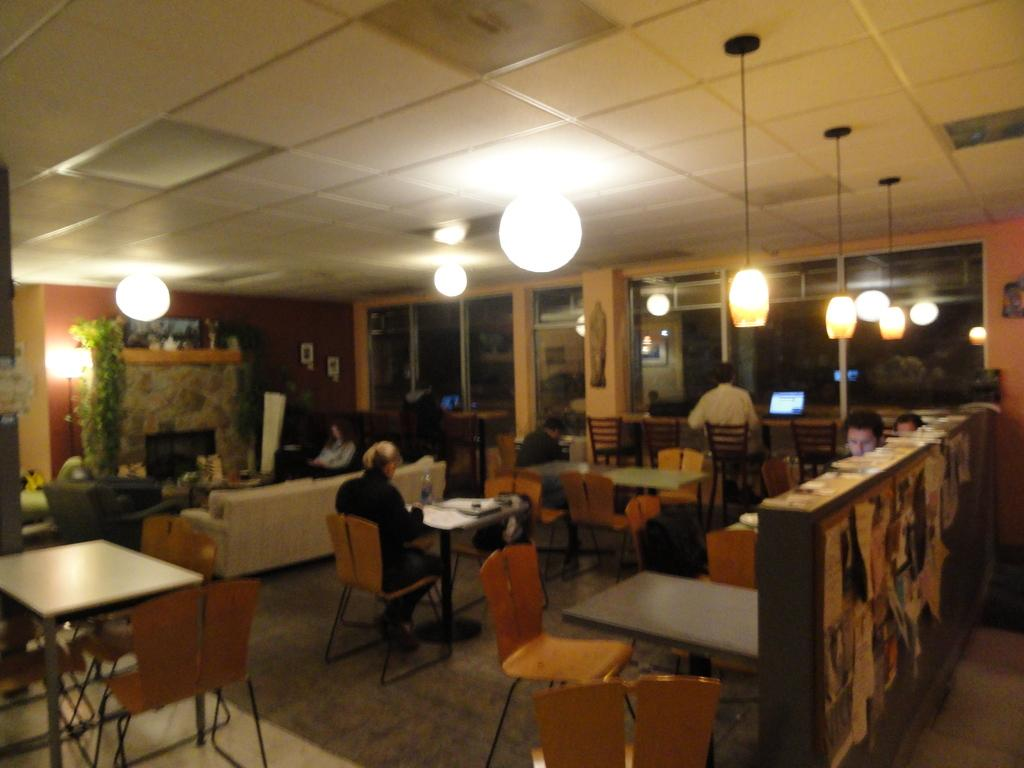What type of furniture is present in the image? There is a table in the image. What is on top of the table? There are objects on the table. Can you describe the person in the image? A person is sitting in the image. What can be seen in the background of the image? There is a wall in the image. What type of illumination is present in the image? There are lights in the image. What architectural feature is visible in the image? There is a door in the image. What type of car is parked in front of the door in the image? There is no car present in the image; it only features a table, objects, a person, a wall, lights, and a door. 